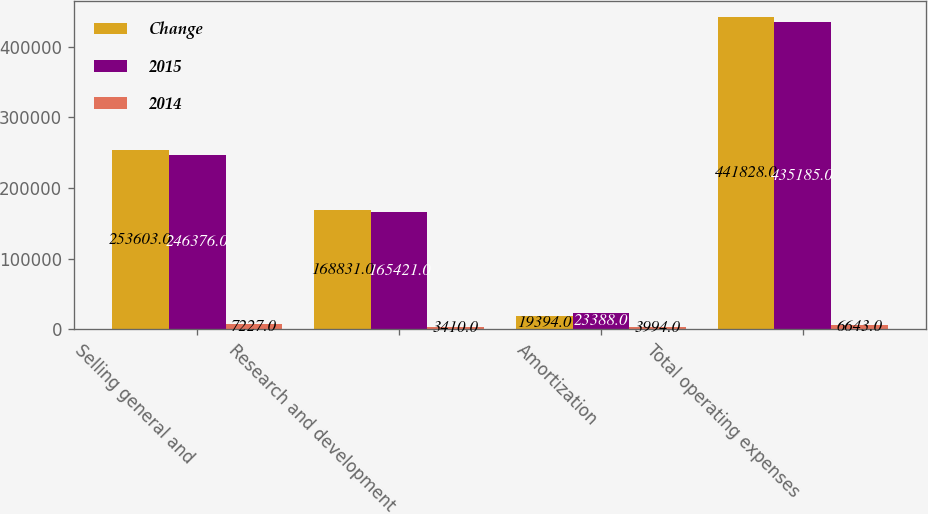<chart> <loc_0><loc_0><loc_500><loc_500><stacked_bar_chart><ecel><fcel>Selling general and<fcel>Research and development<fcel>Amortization<fcel>Total operating expenses<nl><fcel>Change<fcel>253603<fcel>168831<fcel>19394<fcel>441828<nl><fcel>2015<fcel>246376<fcel>165421<fcel>23388<fcel>435185<nl><fcel>2014<fcel>7227<fcel>3410<fcel>3994<fcel>6643<nl></chart> 